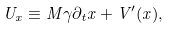<formula> <loc_0><loc_0><loc_500><loc_500>U _ { x } \equiv M \gamma \partial _ { t } x + V ^ { \prime } ( x ) ,</formula> 